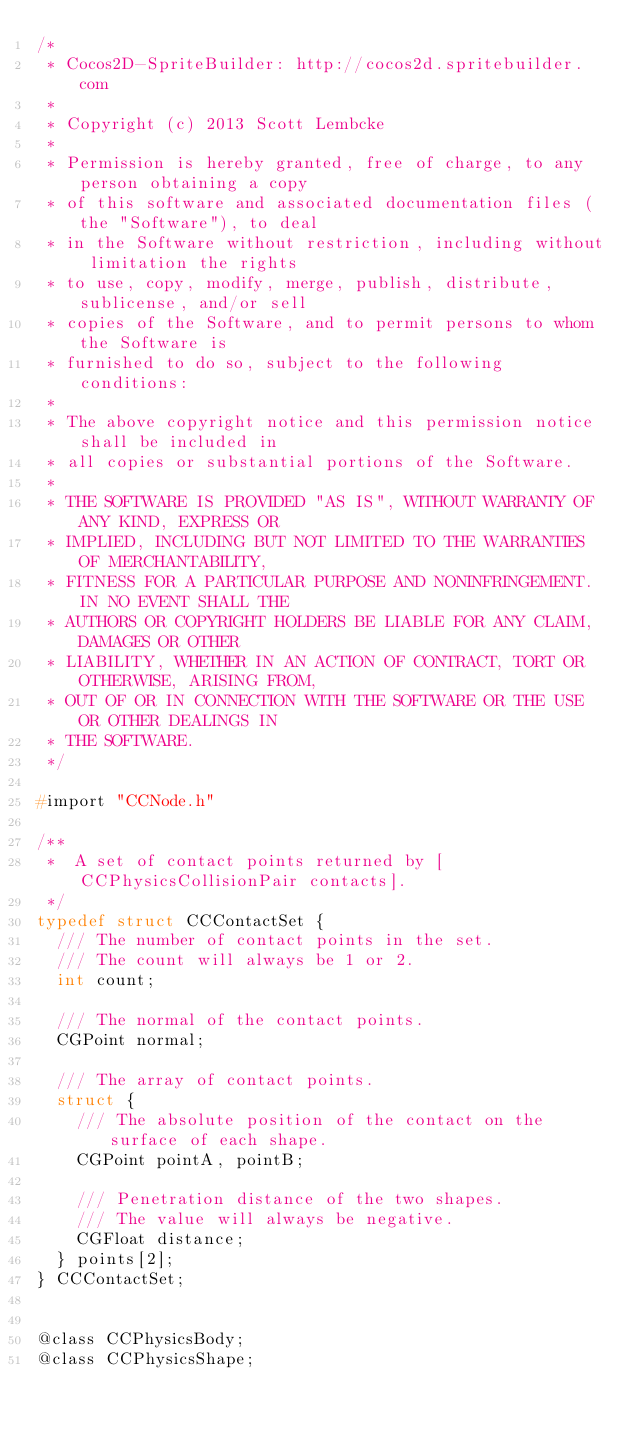Convert code to text. <code><loc_0><loc_0><loc_500><loc_500><_C_>/*
 * Cocos2D-SpriteBuilder: http://cocos2d.spritebuilder.com
 *
 * Copyright (c) 2013 Scott Lembcke
 *
 * Permission is hereby granted, free of charge, to any person obtaining a copy
 * of this software and associated documentation files (the "Software"), to deal
 * in the Software without restriction, including without limitation the rights
 * to use, copy, modify, merge, publish, distribute, sublicense, and/or sell
 * copies of the Software, and to permit persons to whom the Software is
 * furnished to do so, subject to the following conditions:
 *
 * The above copyright notice and this permission notice shall be included in
 * all copies or substantial portions of the Software.
 *
 * THE SOFTWARE IS PROVIDED "AS IS", WITHOUT WARRANTY OF ANY KIND, EXPRESS OR
 * IMPLIED, INCLUDING BUT NOT LIMITED TO THE WARRANTIES OF MERCHANTABILITY,
 * FITNESS FOR A PARTICULAR PURPOSE AND NONINFRINGEMENT. IN NO EVENT SHALL THE
 * AUTHORS OR COPYRIGHT HOLDERS BE LIABLE FOR ANY CLAIM, DAMAGES OR OTHER
 * LIABILITY, WHETHER IN AN ACTION OF CONTRACT, TORT OR OTHERWISE, ARISING FROM,
 * OUT OF OR IN CONNECTION WITH THE SOFTWARE OR THE USE OR OTHER DEALINGS IN
 * THE SOFTWARE.
 */

#import "CCNode.h"

/**
 *  A set of contact points returned by [CCPhysicsCollisionPair contacts].
 */
typedef struct CCContactSet {
	/// The number of contact points in the set.
	/// The count will always be 1 or 2.
	int count;
	
	/// The normal of the contact points.
	CGPoint normal;
	
	/// The array of contact points.
	struct {
		/// The absolute position of the contact on the surface of each shape.
		CGPoint pointA, pointB;
		
		/// Penetration distance of the two shapes.
		/// The value will always be negative.
		CGFloat distance;
	} points[2];
} CCContactSet;


@class CCPhysicsBody;
@class CCPhysicsShape;
</code> 